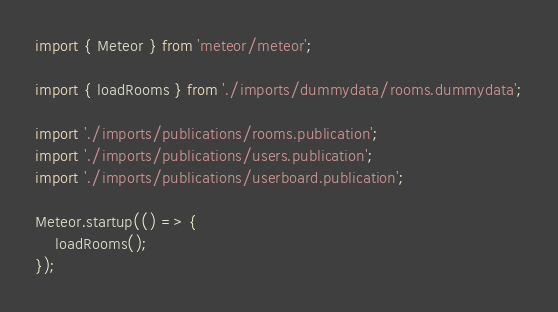<code> <loc_0><loc_0><loc_500><loc_500><_TypeScript_>import { Meteor } from 'meteor/meteor';

import { loadRooms } from './imports/dummydata/rooms.dummydata';

import './imports/publications/rooms.publication';
import './imports/publications/users.publication';
import './imports/publications/userboard.publication';

Meteor.startup(() => {
    loadRooms();
});</code> 